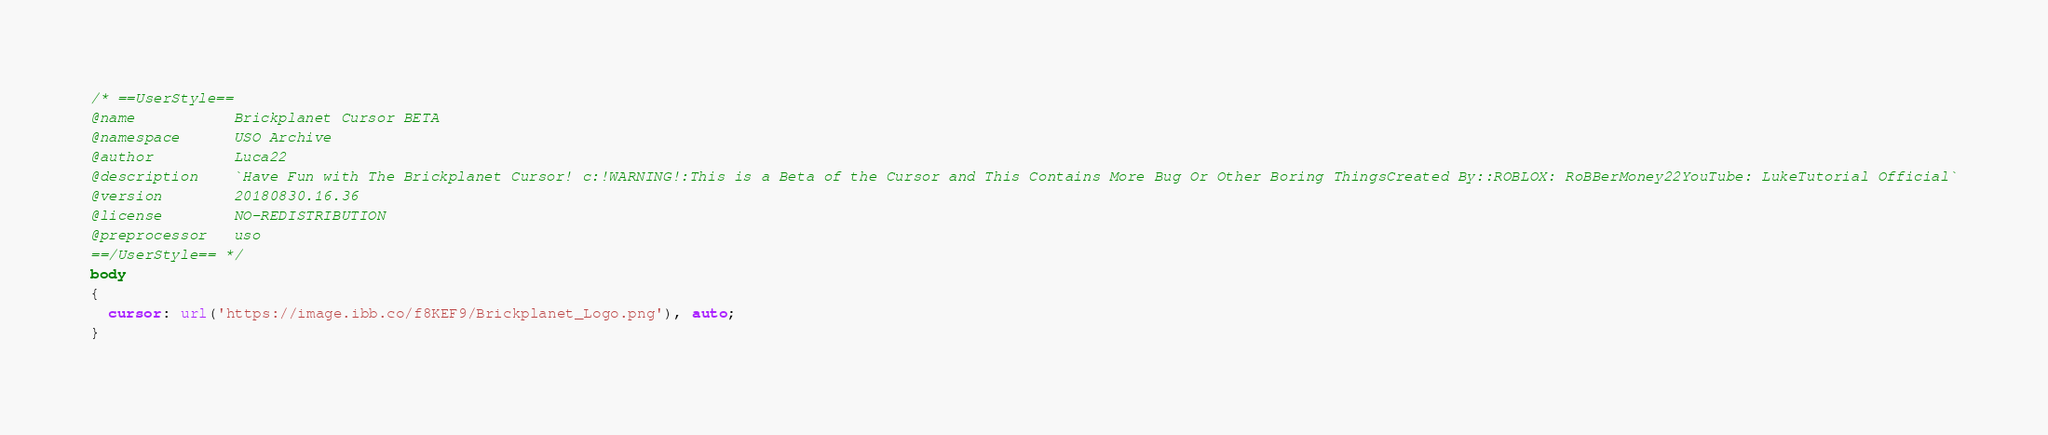<code> <loc_0><loc_0><loc_500><loc_500><_CSS_>/* ==UserStyle==
@name           Brickplanet Cursor BETA
@namespace      USO Archive
@author         Luca22
@description    `Have Fun with The Brickplanet Cursor! c:!WARNING!:This is a Beta of the Cursor and This Contains More Bug Or Other Boring ThingsCreated By::ROBLOX: RoBBerMoney22YouTube: LukeTutorial Official`
@version        20180830.16.36
@license        NO-REDISTRIBUTION
@preprocessor   uso
==/UserStyle== */
body
{
  cursor: url('https://image.ibb.co/f8KEF9/Brickplanet_Logo.png'), auto;
}</code> 